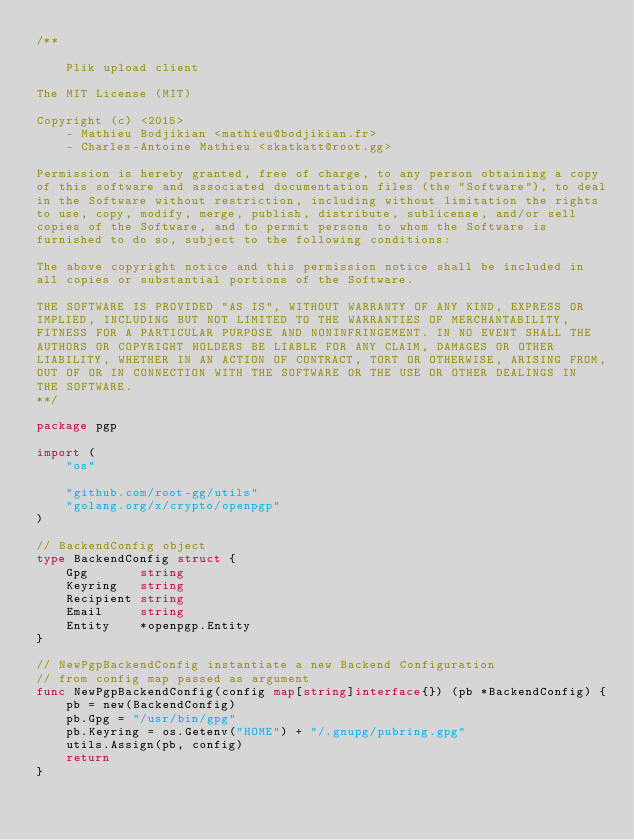Convert code to text. <code><loc_0><loc_0><loc_500><loc_500><_Go_>/**

    Plik upload client

The MIT License (MIT)

Copyright (c) <2015>
	- Mathieu Bodjikian <mathieu@bodjikian.fr>
	- Charles-Antoine Mathieu <skatkatt@root.gg>

Permission is hereby granted, free of charge, to any person obtaining a copy
of this software and associated documentation files (the "Software"), to deal
in the Software without restriction, including without limitation the rights
to use, copy, modify, merge, publish, distribute, sublicense, and/or sell
copies of the Software, and to permit persons to whom the Software is
furnished to do so, subject to the following conditions:

The above copyright notice and this permission notice shall be included in
all copies or substantial portions of the Software.

THE SOFTWARE IS PROVIDED "AS IS", WITHOUT WARRANTY OF ANY KIND, EXPRESS OR
IMPLIED, INCLUDING BUT NOT LIMITED TO THE WARRANTIES OF MERCHANTABILITY,
FITNESS FOR A PARTICULAR PURPOSE AND NONINFRINGEMENT. IN NO EVENT SHALL THE
AUTHORS OR COPYRIGHT HOLDERS BE LIABLE FOR ANY CLAIM, DAMAGES OR OTHER
LIABILITY, WHETHER IN AN ACTION OF CONTRACT, TORT OR OTHERWISE, ARISING FROM,
OUT OF OR IN CONNECTION WITH THE SOFTWARE OR THE USE OR OTHER DEALINGS IN
THE SOFTWARE.
**/

package pgp

import (
	"os"

	"github.com/root-gg/utils"
	"golang.org/x/crypto/openpgp"
)

// BackendConfig object
type BackendConfig struct {
	Gpg       string
	Keyring   string
	Recipient string
	Email     string
	Entity    *openpgp.Entity
}

// NewPgpBackendConfig instantiate a new Backend Configuration
// from config map passed as argument
func NewPgpBackendConfig(config map[string]interface{}) (pb *BackendConfig) {
	pb = new(BackendConfig)
	pb.Gpg = "/usr/bin/gpg"
	pb.Keyring = os.Getenv("HOME") + "/.gnupg/pubring.gpg"
	utils.Assign(pb, config)
	return
}
</code> 